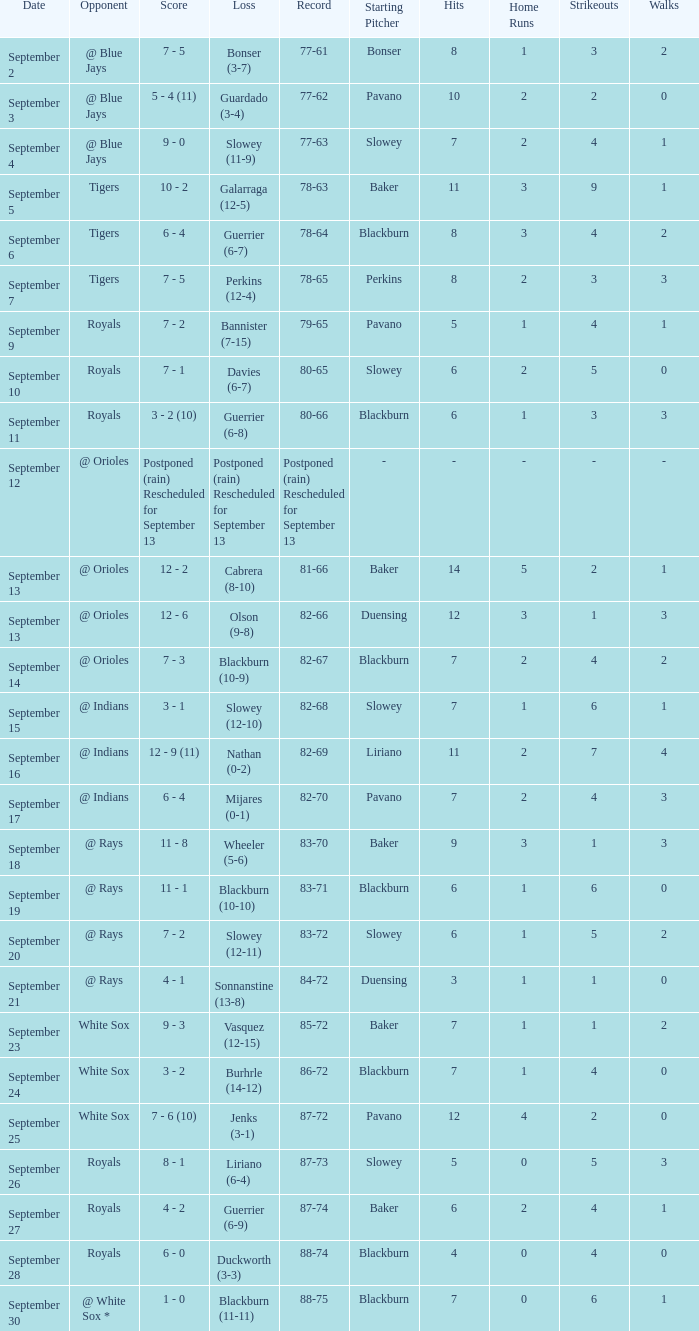What date has the record of 77-62? September 3. 